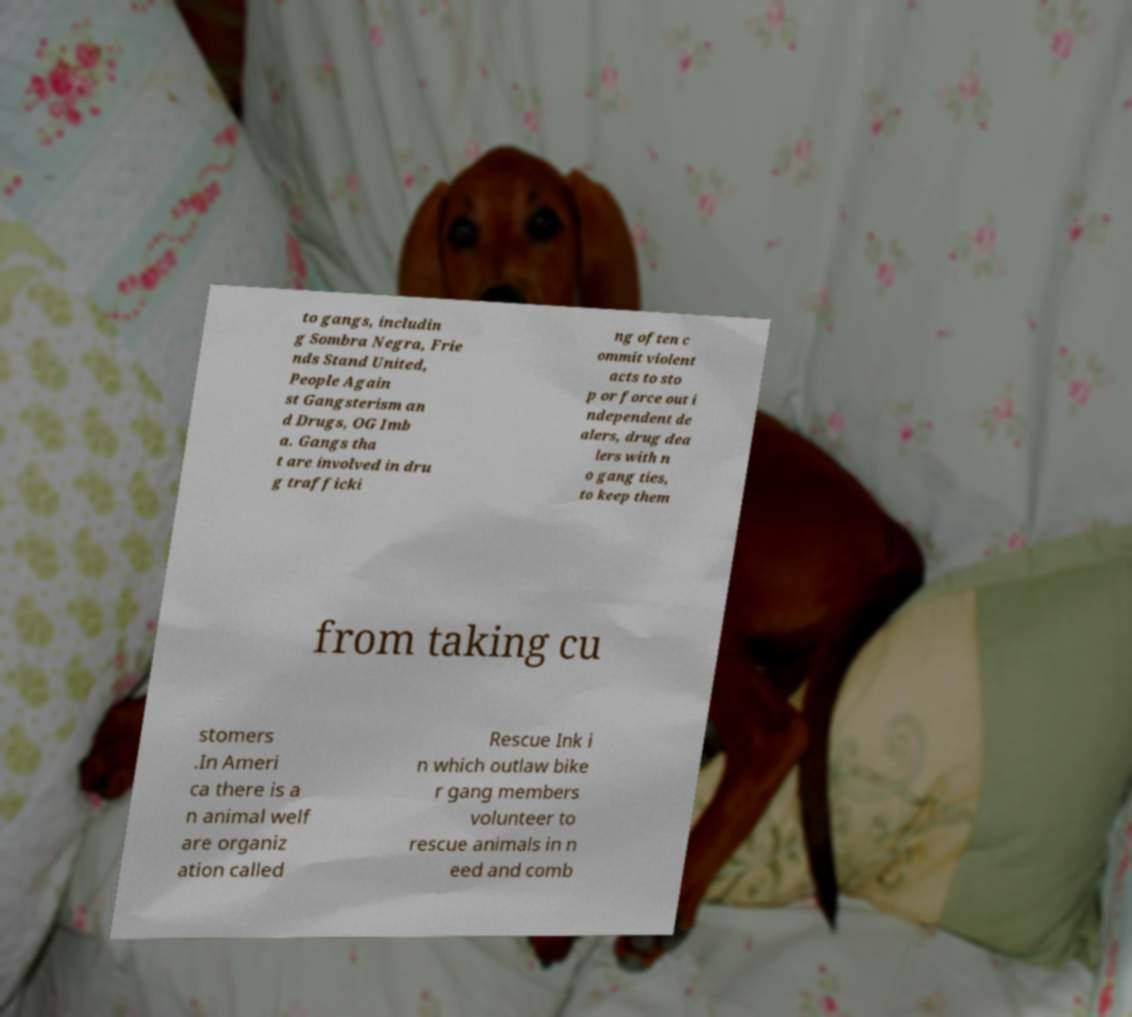Can you accurately transcribe the text from the provided image for me? to gangs, includin g Sombra Negra, Frie nds Stand United, People Again st Gangsterism an d Drugs, OG Imb a. Gangs tha t are involved in dru g trafficki ng often c ommit violent acts to sto p or force out i ndependent de alers, drug dea lers with n o gang ties, to keep them from taking cu stomers .In Ameri ca there is a n animal welf are organiz ation called Rescue Ink i n which outlaw bike r gang members volunteer to rescue animals in n eed and comb 